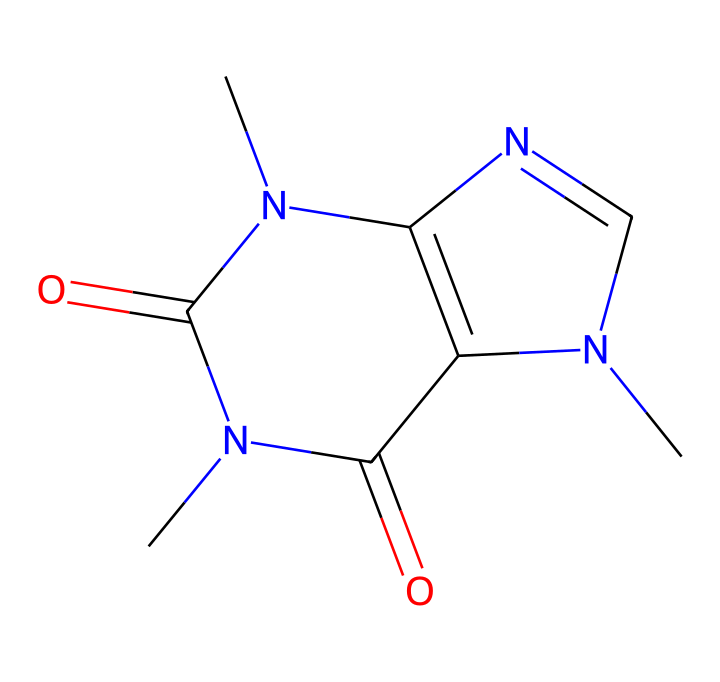what is the name of this chemical? The SMILES representation corresponds to caffeine, which is a common stimulant found in many beverages and snacks, particularly in movie theater concessions.
Answer: caffeine how many nitrogen atoms are in the caffeine molecule? By analyzing the SMILES structure, we can count a total of four nitrogen atoms (N) present in the structure.
Answer: four does this caffeine molecule have cis-trans isomers? Yes, this caffeine molecule can exist in geometric isomer forms due to the presence of double bonds that can create different spatial arrangements.
Answer: yes how many carbon atoms are part of the caffeine molecular structure? The structure can be visualized through the SMILES notation which indicates that there are eight carbon atoms (C) present in the chemical.
Answer: eight what type of isomerism is exhibited by caffeine due to its structure? Caffeine exhibits geometric isomerism among others due to its configuration around the nitrogen atoms involved in double bonding, facilitating cis-trans variations.
Answer: geometric isomerism what is the main functional group found in the caffeine molecule? The caffeine molecule contains carbonyl groups (C=O), which are important in defining its chemical behavior and interactions.
Answer: carbonyl groups 